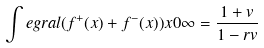Convert formula to latex. <formula><loc_0><loc_0><loc_500><loc_500>\int e g r a l { ( f ^ { + } ( x ) + f ^ { - } ( x ) ) } { x } { 0 } { \infty } = \frac { 1 + v } { 1 - r v }</formula> 